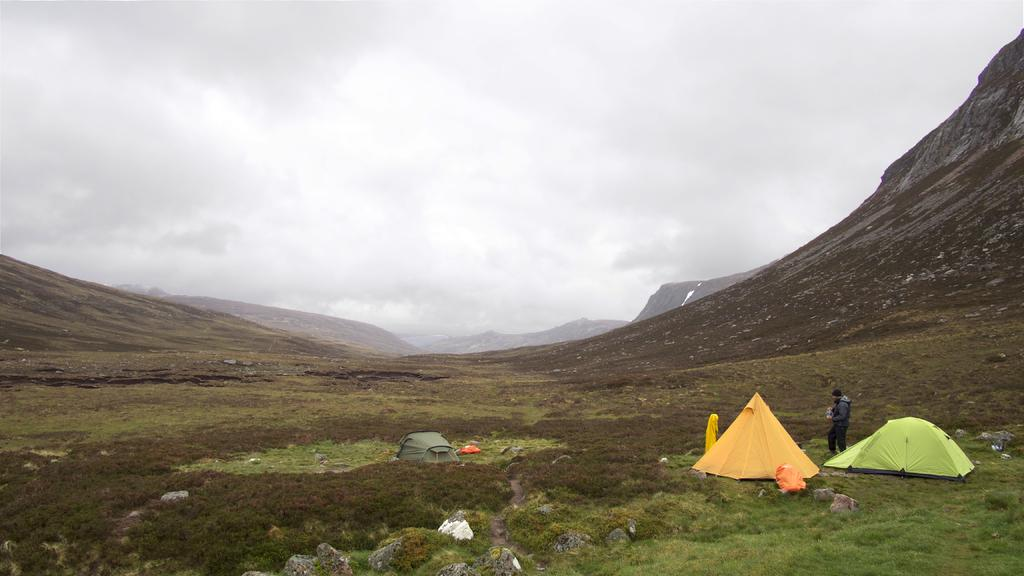Who is present in the image? There is a man in the image. What type of temporary shelters can be seen in the image? There are tents in the image. What type of terrain is visible in the image? There is grass and a hill in the image. What is visible at the top of the image? The sky is visible at the top of the image. How many tickets are required to ride the carriage in the image? There is no carriage present in the image, so the number of tickets required cannot be determined. 